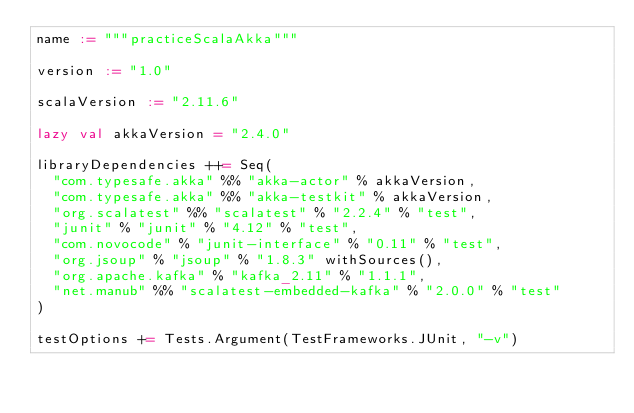<code> <loc_0><loc_0><loc_500><loc_500><_Scala_>name := """practiceScalaAkka"""

version := "1.0"

scalaVersion := "2.11.6"

lazy val akkaVersion = "2.4.0"

libraryDependencies ++= Seq(
  "com.typesafe.akka" %% "akka-actor" % akkaVersion,
  "com.typesafe.akka" %% "akka-testkit" % akkaVersion,
  "org.scalatest" %% "scalatest" % "2.2.4" % "test",
  "junit" % "junit" % "4.12" % "test",
  "com.novocode" % "junit-interface" % "0.11" % "test",
  "org.jsoup" % "jsoup" % "1.8.3" withSources(),
  "org.apache.kafka" % "kafka_2.11" % "1.1.1",
  "net.manub" %% "scalatest-embedded-kafka" % "2.0.0" % "test"
)

testOptions += Tests.Argument(TestFrameworks.JUnit, "-v")
</code> 